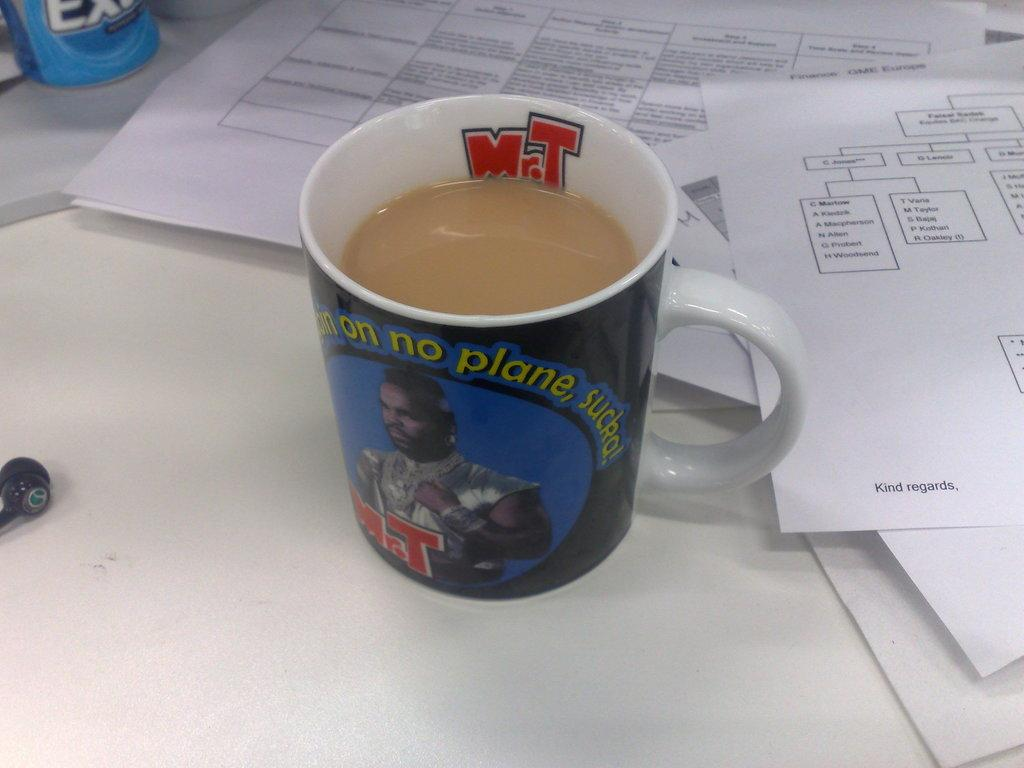Provide a one-sentence caption for the provided image. A functional coffee mug doubles as a vintage piece of Mr. T memorabilia. 